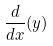<formula> <loc_0><loc_0><loc_500><loc_500>\frac { d } { d x } ( y )</formula> 